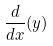<formula> <loc_0><loc_0><loc_500><loc_500>\frac { d } { d x } ( y )</formula> 